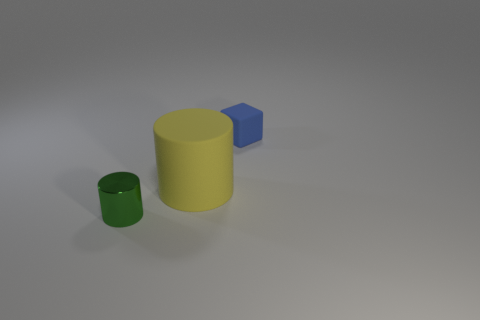Add 3 tiny blue blocks. How many objects exist? 6 Subtract all cylinders. How many objects are left? 1 Add 3 small green metallic things. How many small green metallic things are left? 4 Add 1 large red rubber cylinders. How many large red rubber cylinders exist? 1 Subtract 0 yellow balls. How many objects are left? 3 Subtract all green metal objects. Subtract all green metallic balls. How many objects are left? 2 